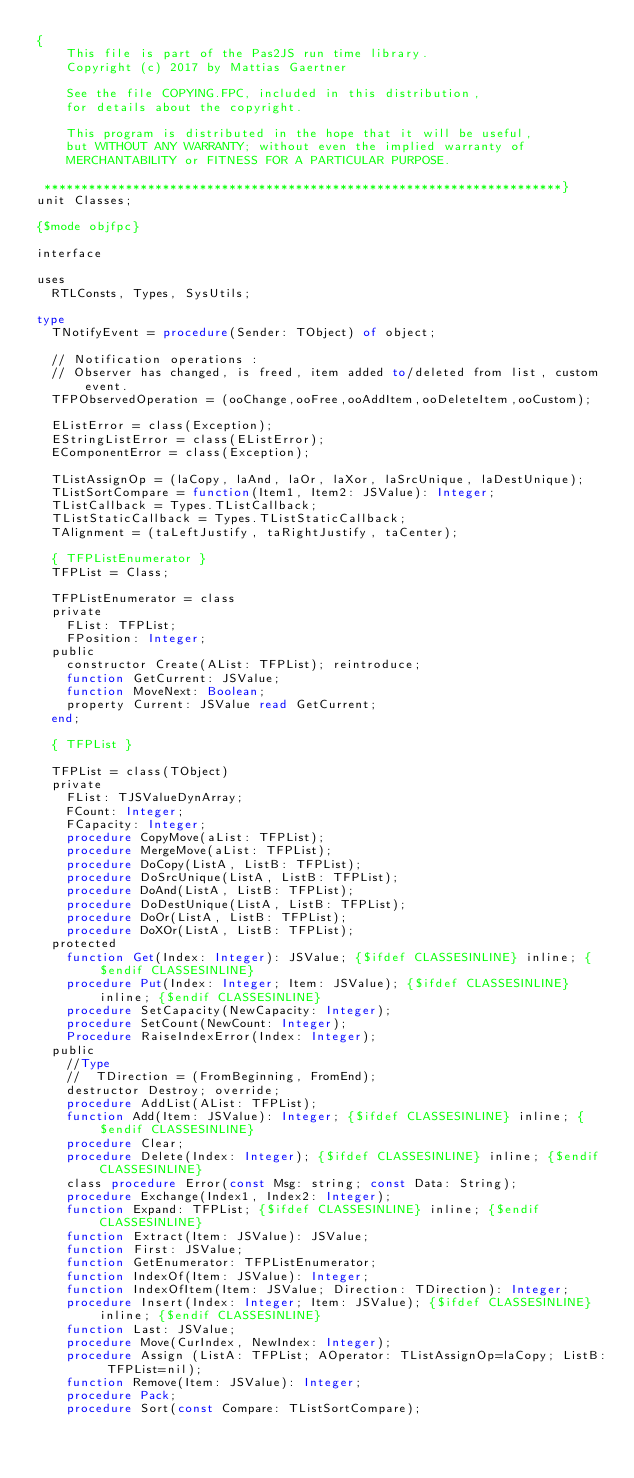Convert code to text. <code><loc_0><loc_0><loc_500><loc_500><_Pascal_>{
    This file is part of the Pas2JS run time library.
    Copyright (c) 2017 by Mattias Gaertner

    See the file COPYING.FPC, included in this distribution,
    for details about the copyright.

    This program is distributed in the hope that it will be useful,
    but WITHOUT ANY WARRANTY; without even the implied warranty of
    MERCHANTABILITY or FITNESS FOR A PARTICULAR PURPOSE.

 **********************************************************************}
unit Classes;

{$mode objfpc}

interface

uses
  RTLConsts, Types, SysUtils;

type
  TNotifyEvent = procedure(Sender: TObject) of object;

  // Notification operations :
  // Observer has changed, is freed, item added to/deleted from list, custom event.
  TFPObservedOperation = (ooChange,ooFree,ooAddItem,ooDeleteItem,ooCustom);

  EListError = class(Exception);
  EStringListError = class(EListError);
  EComponentError = class(Exception);

  TListAssignOp = (laCopy, laAnd, laOr, laXor, laSrcUnique, laDestUnique);
  TListSortCompare = function(Item1, Item2: JSValue): Integer;
  TListCallback = Types.TListCallback;
  TListStaticCallback = Types.TListStaticCallback;
  TAlignment = (taLeftJustify, taRightJustify, taCenter);

  { TFPListEnumerator }
  TFPList = Class;

  TFPListEnumerator = class
  private
    FList: TFPList;
    FPosition: Integer;
  public
    constructor Create(AList: TFPList); reintroduce;
    function GetCurrent: JSValue;
    function MoveNext: Boolean;
    property Current: JSValue read GetCurrent;
  end;

  { TFPList }

  TFPList = class(TObject)
  private
    FList: TJSValueDynArray;
    FCount: Integer;
    FCapacity: Integer;
    procedure CopyMove(aList: TFPList);
    procedure MergeMove(aList: TFPList);
    procedure DoCopy(ListA, ListB: TFPList);
    procedure DoSrcUnique(ListA, ListB: TFPList);
    procedure DoAnd(ListA, ListB: TFPList);
    procedure DoDestUnique(ListA, ListB: TFPList);
    procedure DoOr(ListA, ListB: TFPList);
    procedure DoXOr(ListA, ListB: TFPList);
  protected
    function Get(Index: Integer): JSValue; {$ifdef CLASSESINLINE} inline; {$endif CLASSESINLINE}
    procedure Put(Index: Integer; Item: JSValue); {$ifdef CLASSESINLINE} inline; {$endif CLASSESINLINE}
    procedure SetCapacity(NewCapacity: Integer);
    procedure SetCount(NewCount: Integer);
    Procedure RaiseIndexError(Index: Integer);
  public
    //Type
    //  TDirection = (FromBeginning, FromEnd);
    destructor Destroy; override;
    procedure AddList(AList: TFPList);
    function Add(Item: JSValue): Integer; {$ifdef CLASSESINLINE} inline; {$endif CLASSESINLINE}
    procedure Clear;
    procedure Delete(Index: Integer); {$ifdef CLASSESINLINE} inline; {$endif CLASSESINLINE}
    class procedure Error(const Msg: string; const Data: String);
    procedure Exchange(Index1, Index2: Integer);
    function Expand: TFPList; {$ifdef CLASSESINLINE} inline; {$endif CLASSESINLINE}
    function Extract(Item: JSValue): JSValue;
    function First: JSValue;
    function GetEnumerator: TFPListEnumerator;
    function IndexOf(Item: JSValue): Integer;
    function IndexOfItem(Item: JSValue; Direction: TDirection): Integer;
    procedure Insert(Index: Integer; Item: JSValue); {$ifdef CLASSESINLINE} inline; {$endif CLASSESINLINE}
    function Last: JSValue;
    procedure Move(CurIndex, NewIndex: Integer);
    procedure Assign (ListA: TFPList; AOperator: TListAssignOp=laCopy; ListB: TFPList=nil);
    function Remove(Item: JSValue): Integer;
    procedure Pack;
    procedure Sort(const Compare: TListSortCompare);</code> 